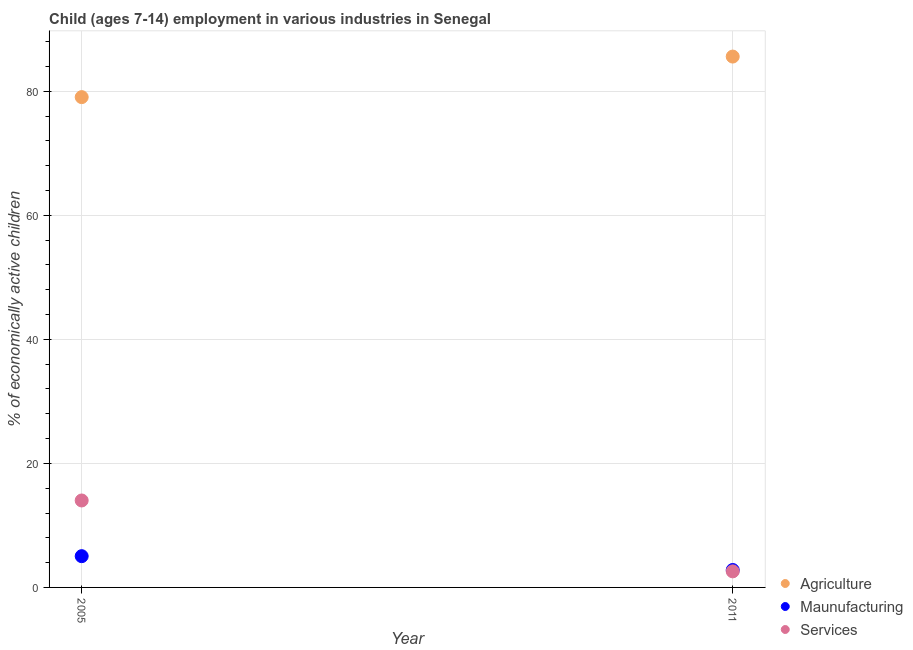How many different coloured dotlines are there?
Keep it short and to the point. 3. What is the percentage of economically active children in agriculture in 2011?
Keep it short and to the point. 85.6. Across all years, what is the maximum percentage of economically active children in services?
Ensure brevity in your answer.  14.02. Across all years, what is the minimum percentage of economically active children in agriculture?
Make the answer very short. 79.06. In which year was the percentage of economically active children in agriculture minimum?
Your answer should be very brief. 2005. What is the total percentage of economically active children in services in the graph?
Make the answer very short. 16.61. What is the difference between the percentage of economically active children in manufacturing in 2005 and that in 2011?
Keep it short and to the point. 2.23. What is the difference between the percentage of economically active children in manufacturing in 2011 and the percentage of economically active children in agriculture in 2005?
Make the answer very short. -76.25. What is the average percentage of economically active children in agriculture per year?
Your answer should be very brief. 82.33. In the year 2005, what is the difference between the percentage of economically active children in manufacturing and percentage of economically active children in services?
Offer a very short reply. -8.98. What is the ratio of the percentage of economically active children in services in 2005 to that in 2011?
Your answer should be compact. 5.41. Is the percentage of economically active children in agriculture in 2005 less than that in 2011?
Your response must be concise. Yes. Does the percentage of economically active children in agriculture monotonically increase over the years?
Your answer should be very brief. Yes. Is the percentage of economically active children in agriculture strictly less than the percentage of economically active children in manufacturing over the years?
Your answer should be very brief. No. What is the difference between two consecutive major ticks on the Y-axis?
Provide a succinct answer. 20. Are the values on the major ticks of Y-axis written in scientific E-notation?
Offer a terse response. No. Does the graph contain any zero values?
Keep it short and to the point. No. How many legend labels are there?
Keep it short and to the point. 3. What is the title of the graph?
Your response must be concise. Child (ages 7-14) employment in various industries in Senegal. Does "Manufactures" appear as one of the legend labels in the graph?
Give a very brief answer. No. What is the label or title of the X-axis?
Provide a short and direct response. Year. What is the label or title of the Y-axis?
Give a very brief answer. % of economically active children. What is the % of economically active children of Agriculture in 2005?
Provide a short and direct response. 79.06. What is the % of economically active children of Maunufacturing in 2005?
Your answer should be compact. 5.04. What is the % of economically active children of Services in 2005?
Your answer should be very brief. 14.02. What is the % of economically active children in Agriculture in 2011?
Provide a short and direct response. 85.6. What is the % of economically active children in Maunufacturing in 2011?
Ensure brevity in your answer.  2.81. What is the % of economically active children in Services in 2011?
Provide a short and direct response. 2.59. Across all years, what is the maximum % of economically active children in Agriculture?
Make the answer very short. 85.6. Across all years, what is the maximum % of economically active children of Maunufacturing?
Your answer should be compact. 5.04. Across all years, what is the maximum % of economically active children in Services?
Provide a short and direct response. 14.02. Across all years, what is the minimum % of economically active children of Agriculture?
Offer a terse response. 79.06. Across all years, what is the minimum % of economically active children in Maunufacturing?
Offer a very short reply. 2.81. Across all years, what is the minimum % of economically active children of Services?
Offer a very short reply. 2.59. What is the total % of economically active children of Agriculture in the graph?
Provide a short and direct response. 164.66. What is the total % of economically active children in Maunufacturing in the graph?
Your response must be concise. 7.85. What is the total % of economically active children in Services in the graph?
Provide a short and direct response. 16.61. What is the difference between the % of economically active children of Agriculture in 2005 and that in 2011?
Offer a terse response. -6.54. What is the difference between the % of economically active children of Maunufacturing in 2005 and that in 2011?
Give a very brief answer. 2.23. What is the difference between the % of economically active children of Services in 2005 and that in 2011?
Ensure brevity in your answer.  11.43. What is the difference between the % of economically active children of Agriculture in 2005 and the % of economically active children of Maunufacturing in 2011?
Offer a terse response. 76.25. What is the difference between the % of economically active children of Agriculture in 2005 and the % of economically active children of Services in 2011?
Ensure brevity in your answer.  76.47. What is the difference between the % of economically active children in Maunufacturing in 2005 and the % of economically active children in Services in 2011?
Your answer should be compact. 2.45. What is the average % of economically active children of Agriculture per year?
Give a very brief answer. 82.33. What is the average % of economically active children in Maunufacturing per year?
Give a very brief answer. 3.92. What is the average % of economically active children of Services per year?
Provide a succinct answer. 8.3. In the year 2005, what is the difference between the % of economically active children of Agriculture and % of economically active children of Maunufacturing?
Offer a very short reply. 74.02. In the year 2005, what is the difference between the % of economically active children of Agriculture and % of economically active children of Services?
Ensure brevity in your answer.  65.04. In the year 2005, what is the difference between the % of economically active children in Maunufacturing and % of economically active children in Services?
Provide a succinct answer. -8.98. In the year 2011, what is the difference between the % of economically active children of Agriculture and % of economically active children of Maunufacturing?
Your answer should be compact. 82.79. In the year 2011, what is the difference between the % of economically active children in Agriculture and % of economically active children in Services?
Offer a very short reply. 83.01. In the year 2011, what is the difference between the % of economically active children of Maunufacturing and % of economically active children of Services?
Keep it short and to the point. 0.22. What is the ratio of the % of economically active children in Agriculture in 2005 to that in 2011?
Your response must be concise. 0.92. What is the ratio of the % of economically active children of Maunufacturing in 2005 to that in 2011?
Offer a terse response. 1.79. What is the ratio of the % of economically active children of Services in 2005 to that in 2011?
Offer a terse response. 5.41. What is the difference between the highest and the second highest % of economically active children of Agriculture?
Your answer should be compact. 6.54. What is the difference between the highest and the second highest % of economically active children in Maunufacturing?
Offer a very short reply. 2.23. What is the difference between the highest and the second highest % of economically active children of Services?
Provide a short and direct response. 11.43. What is the difference between the highest and the lowest % of economically active children of Agriculture?
Your answer should be very brief. 6.54. What is the difference between the highest and the lowest % of economically active children of Maunufacturing?
Provide a short and direct response. 2.23. What is the difference between the highest and the lowest % of economically active children in Services?
Provide a short and direct response. 11.43. 